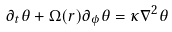Convert formula to latex. <formula><loc_0><loc_0><loc_500><loc_500>\partial _ { t } \theta + \Omega ( r ) \partial _ { \phi } \theta = \kappa \nabla ^ { 2 } \theta</formula> 